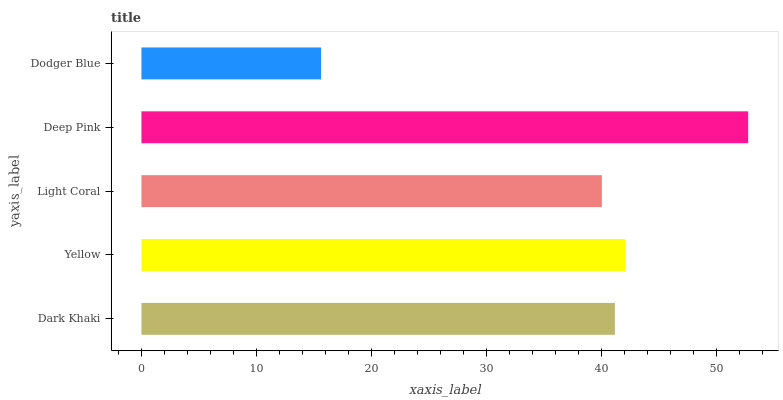Is Dodger Blue the minimum?
Answer yes or no. Yes. Is Deep Pink the maximum?
Answer yes or no. Yes. Is Yellow the minimum?
Answer yes or no. No. Is Yellow the maximum?
Answer yes or no. No. Is Yellow greater than Dark Khaki?
Answer yes or no. Yes. Is Dark Khaki less than Yellow?
Answer yes or no. Yes. Is Dark Khaki greater than Yellow?
Answer yes or no. No. Is Yellow less than Dark Khaki?
Answer yes or no. No. Is Dark Khaki the high median?
Answer yes or no. Yes. Is Dark Khaki the low median?
Answer yes or no. Yes. Is Dodger Blue the high median?
Answer yes or no. No. Is Light Coral the low median?
Answer yes or no. No. 